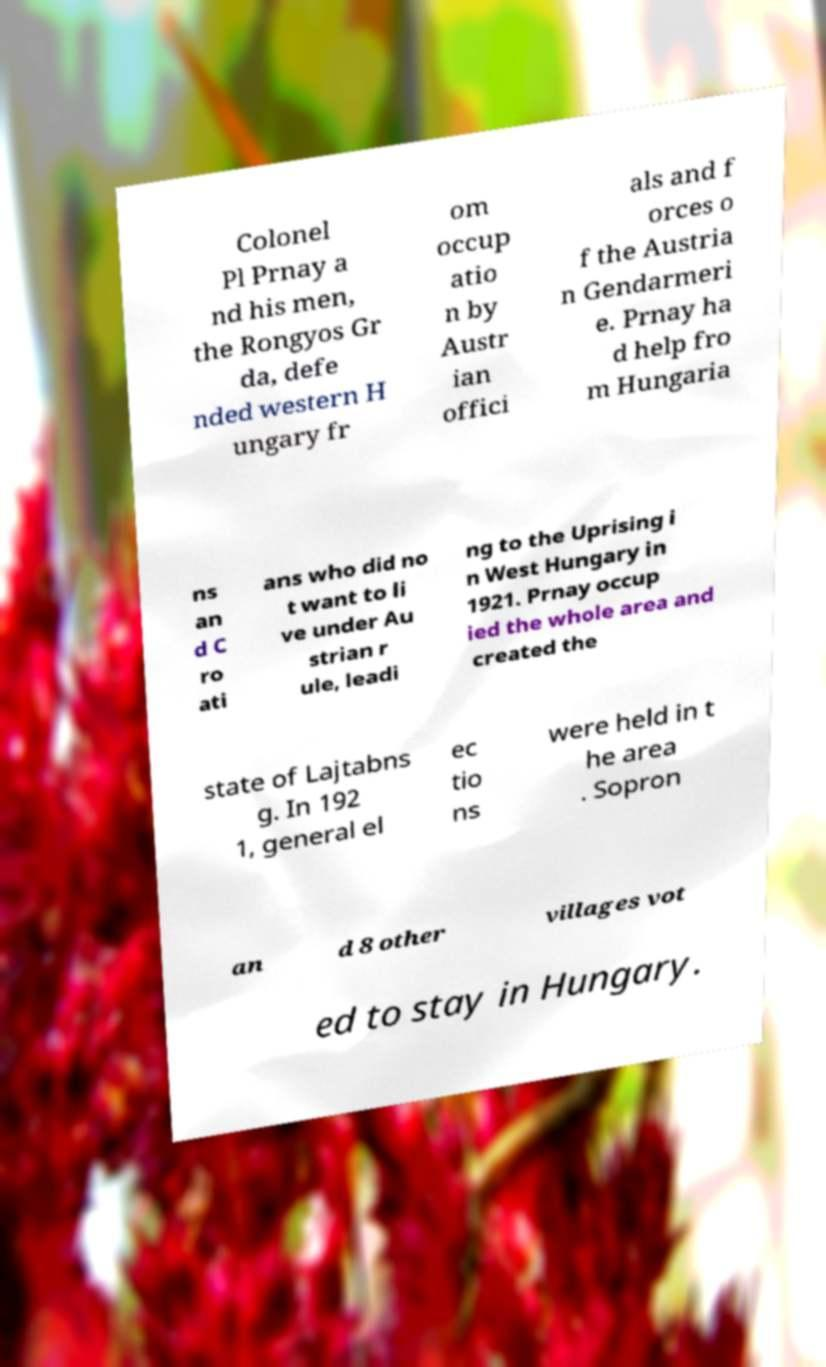What messages or text are displayed in this image? I need them in a readable, typed format. Colonel Pl Prnay a nd his men, the Rongyos Gr da, defe nded western H ungary fr om occup atio n by Austr ian offici als and f orces o f the Austria n Gendarmeri e. Prnay ha d help fro m Hungaria ns an d C ro ati ans who did no t want to li ve under Au strian r ule, leadi ng to the Uprising i n West Hungary in 1921. Prnay occup ied the whole area and created the state of Lajtabns g. In 192 1, general el ec tio ns were held in t he area . Sopron an d 8 other villages vot ed to stay in Hungary. 